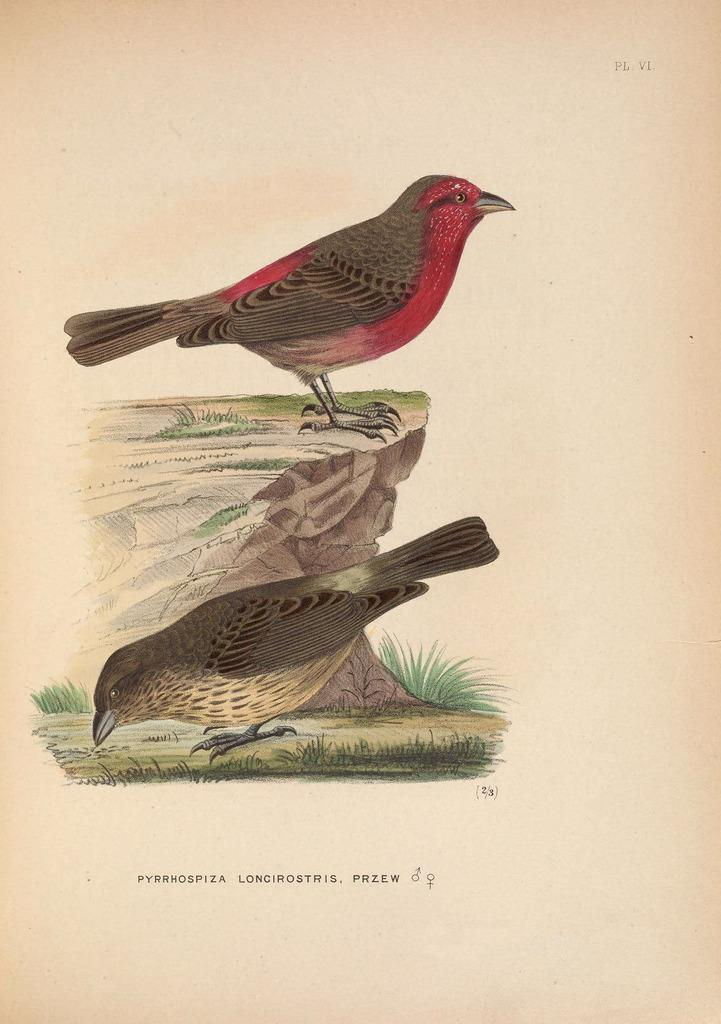What is depicted in the drawing in the image? There is a drawing of two birds in the image. Where is one of the birds located in the drawing? One bird is on the wall in the drawing. Where is the other bird located in the drawing? The other bird is on the ground in the drawing. What can be found at the bottom of the image? There is text written at the bottom of the image. Can you see the birds kissing each other in the image? There is no indication of the birds kissing in the image; they are simply depicted in different locations. 